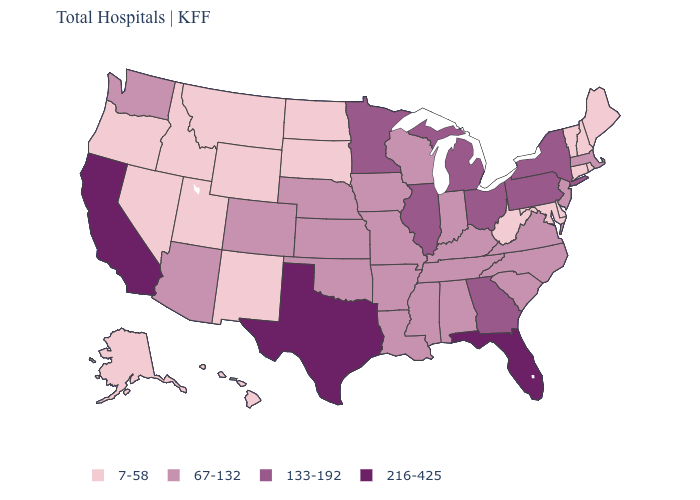Among the states that border Idaho , which have the highest value?
Give a very brief answer. Washington. What is the highest value in the USA?
Write a very short answer. 216-425. What is the lowest value in the USA?
Answer briefly. 7-58. What is the lowest value in the USA?
Write a very short answer. 7-58. Does the map have missing data?
Short answer required. No. Which states have the highest value in the USA?
Be succinct. California, Florida, Texas. Name the states that have a value in the range 67-132?
Answer briefly. Alabama, Arizona, Arkansas, Colorado, Indiana, Iowa, Kansas, Kentucky, Louisiana, Massachusetts, Mississippi, Missouri, Nebraska, New Jersey, North Carolina, Oklahoma, South Carolina, Tennessee, Virginia, Washington, Wisconsin. Does Nevada have the highest value in the USA?
Write a very short answer. No. Name the states that have a value in the range 67-132?
Short answer required. Alabama, Arizona, Arkansas, Colorado, Indiana, Iowa, Kansas, Kentucky, Louisiana, Massachusetts, Mississippi, Missouri, Nebraska, New Jersey, North Carolina, Oklahoma, South Carolina, Tennessee, Virginia, Washington, Wisconsin. How many symbols are there in the legend?
Quick response, please. 4. Does New York have the highest value in the Northeast?
Be succinct. Yes. Name the states that have a value in the range 216-425?
Short answer required. California, Florida, Texas. What is the highest value in the USA?
Answer briefly. 216-425. What is the value of Pennsylvania?
Give a very brief answer. 133-192. What is the lowest value in the South?
Write a very short answer. 7-58. 